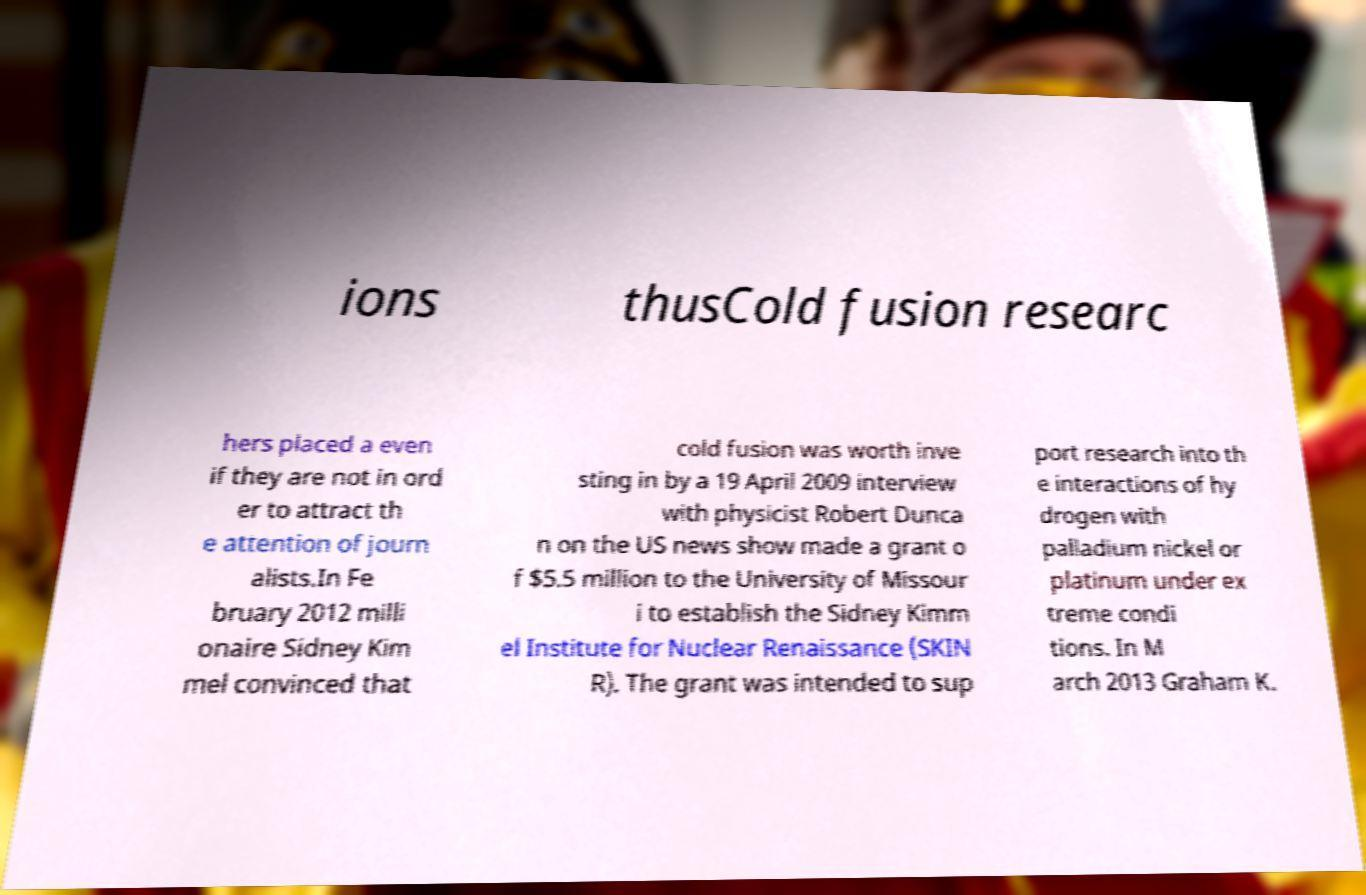There's text embedded in this image that I need extracted. Can you transcribe it verbatim? ions thusCold fusion researc hers placed a even if they are not in ord er to attract th e attention of journ alists.In Fe bruary 2012 milli onaire Sidney Kim mel convinced that cold fusion was worth inve sting in by a 19 April 2009 interview with physicist Robert Dunca n on the US news show made a grant o f $5.5 million to the University of Missour i to establish the Sidney Kimm el Institute for Nuclear Renaissance (SKIN R). The grant was intended to sup port research into th e interactions of hy drogen with palladium nickel or platinum under ex treme condi tions. In M arch 2013 Graham K. 